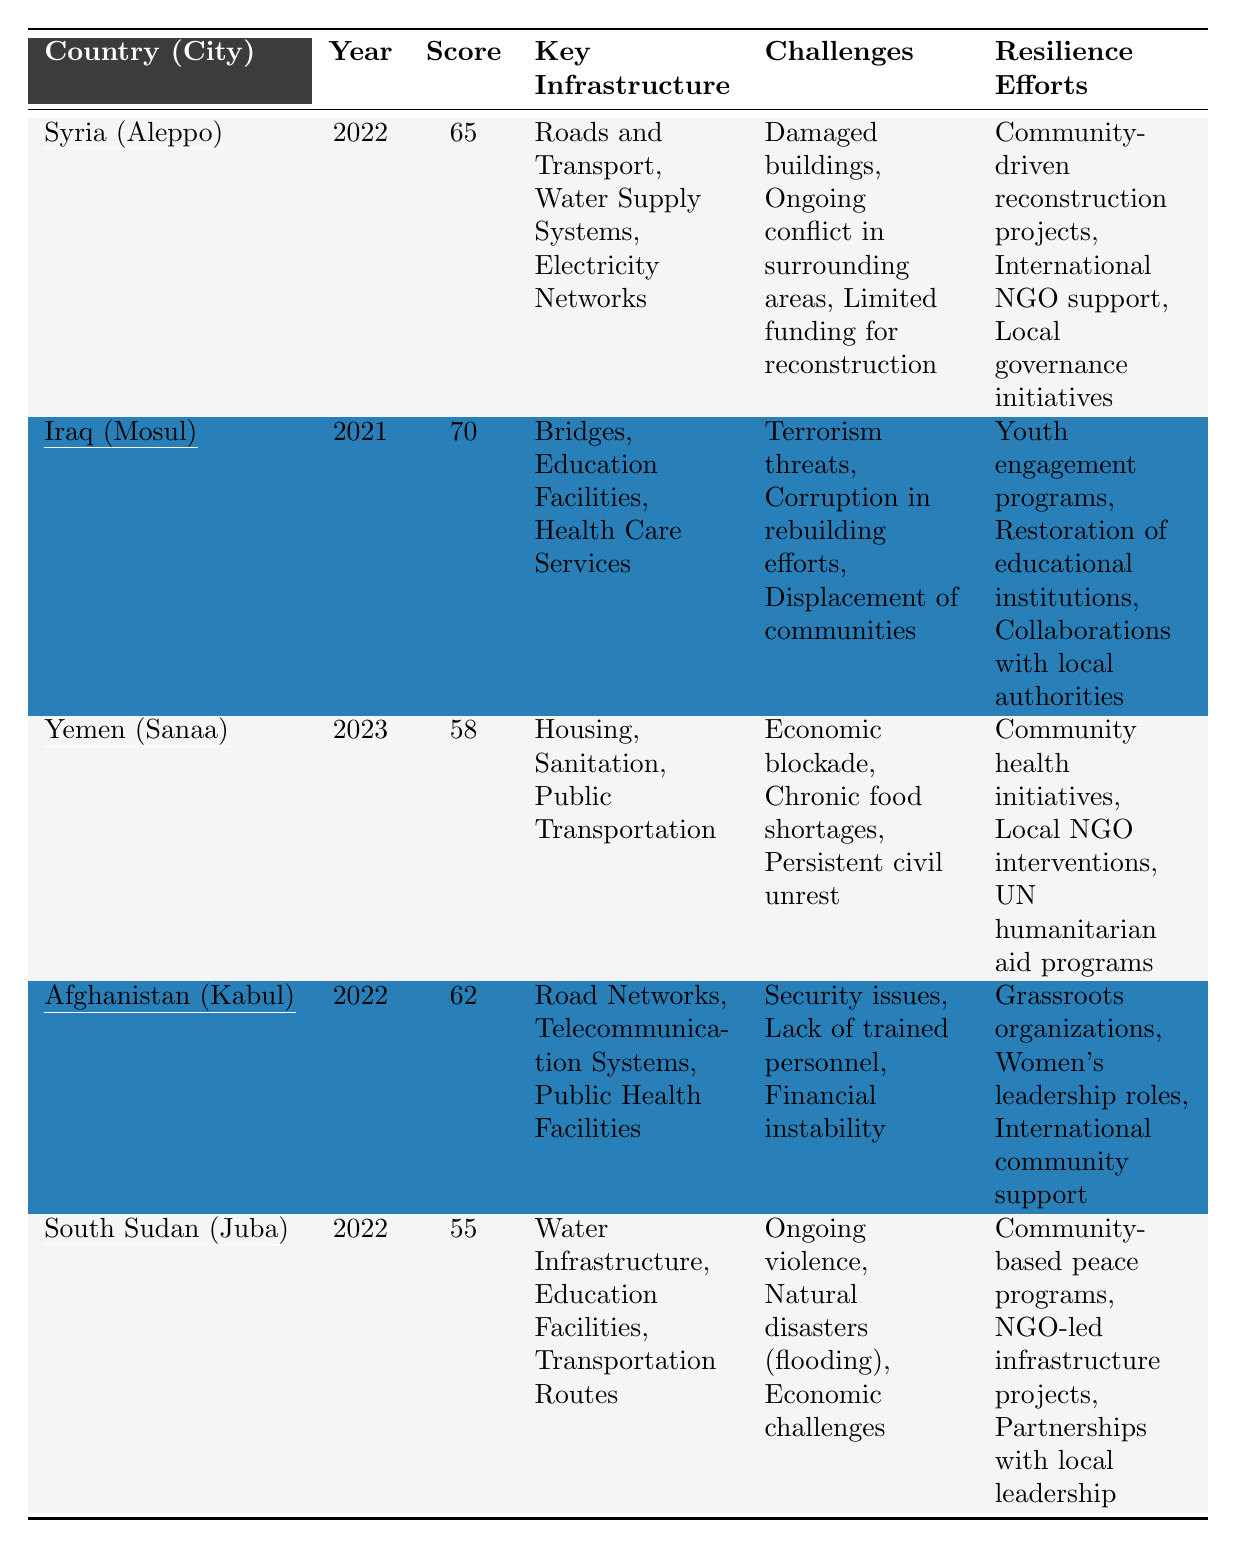What's the assessment score for Yemen (Sanaa)? The assessment score for Yemen (Sanaa) is listed in the table as 58.
Answer: 58 Which country has the highest assessment score? By examining the scores in the table, Iraq (Mosul) has the highest score of 70.
Answer: Iraq (Mosul) What are the key infrastructure types in Syria (Aleppo)? The key infrastructure types for Syria (Aleppo) are Roads and Transport, Water Supply Systems, and Electricity Networks, as stated in the table.
Answer: Roads and Transport, Water Supply Systems, Electricity Networks Is the assessment score for Afghanistan (Kabul) higher than that for South Sudan (Juba)? The assessment score for Afghanistan (Kabul) is 62, while South Sudan (Juba) is 55, making Afghanistan (Kabul) higher.
Answer: Yes What are the challenges faced in Iraq (Mosul)? The challenges listed for Iraq (Mosul) include Terrorism threats, Corruption in rebuilding efforts, and Displacement of communities according to the table.
Answer: Terrorism threats, Corruption in rebuilding efforts, Displacement of communities What is the average assessment score for the countries listed in the table? The scores are 65 (Syria) + 70 (Iraq) + 58 (Yemen) + 62 (Afghanistan) + 55 (South Sudan) = 310. Dividing by 5 (the number of countries) gives an average score of 62.
Answer: 62 Does Yemen (Sanaa) have any resilience efforts listed? Yes, the resilience efforts for Yemen (Sanaa) include Community health initiatives, Local NGO interventions, and UN humanitarian aid programs, as shown in the table.
Answer: Yes Which city has the lowest infrastructure recovery score? The table indicates that South Sudan (Juba) has the lowest score of 55, compared to the other cities listed.
Answer: South Sudan (Juba) What specific resilience efforts are mentioned for Afghanistan (Kabul)? The resilience efforts for Afghanistan (Kabul) include Grassroots organizations, Women's leadership roles, and International community support, according to the table.
Answer: Grassroots organizations, Women's leadership roles, International community support What are the economic challenges noted for South Sudan (Juba)? The economic challenges listed for South Sudan (Juba) are Ongoing violence, Natural disasters (flooding), and Economic challenges.
Answer: Ongoing violence, Natural disasters (flooding), Economic challenges 